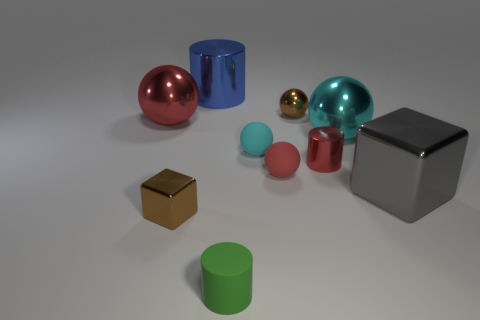There is a shiny object that is the same color as the small shiny sphere; what shape is it?
Give a very brief answer. Cube. There is a red ball that is on the right side of the small matte cylinder that is in front of the small brown metal cube; what is its material?
Your answer should be compact. Rubber. What number of small metal objects are to the right of the tiny cyan rubber sphere and in front of the tiny cyan sphere?
Keep it short and to the point. 1. How many other things are the same size as the cyan rubber thing?
Keep it short and to the point. 5. Do the tiny brown shiny thing in front of the red cylinder and the gray object right of the tiny matte cylinder have the same shape?
Keep it short and to the point. Yes. Are there any cyan metal things to the right of the brown cube?
Ensure brevity in your answer.  Yes. What is the color of the other tiny rubber object that is the same shape as the small red rubber object?
Give a very brief answer. Cyan. Is there anything else that is the same shape as the big cyan object?
Give a very brief answer. Yes. There is a red ball that is in front of the cyan metallic ball; what is its material?
Ensure brevity in your answer.  Rubber. What size is the red metallic object that is the same shape as the small green rubber object?
Make the answer very short. Small. 